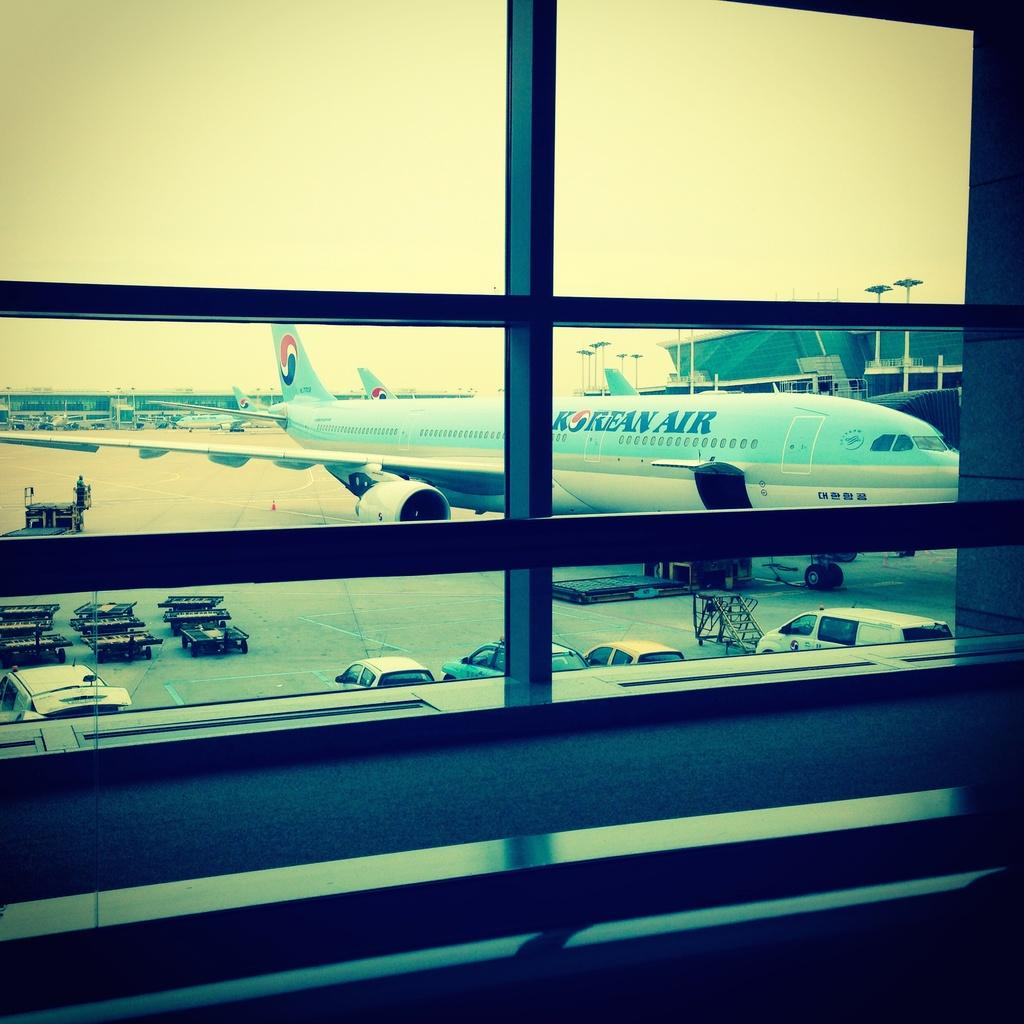<image>
Write a terse but informative summary of the picture. A Korean Air Airplane as seen through a picture window. 